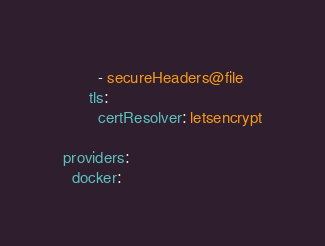<code> <loc_0><loc_0><loc_500><loc_500><_YAML_>        - secureHeaders@file
      tls:
        certResolver: letsencrypt
              
providers:
  docker:</code> 